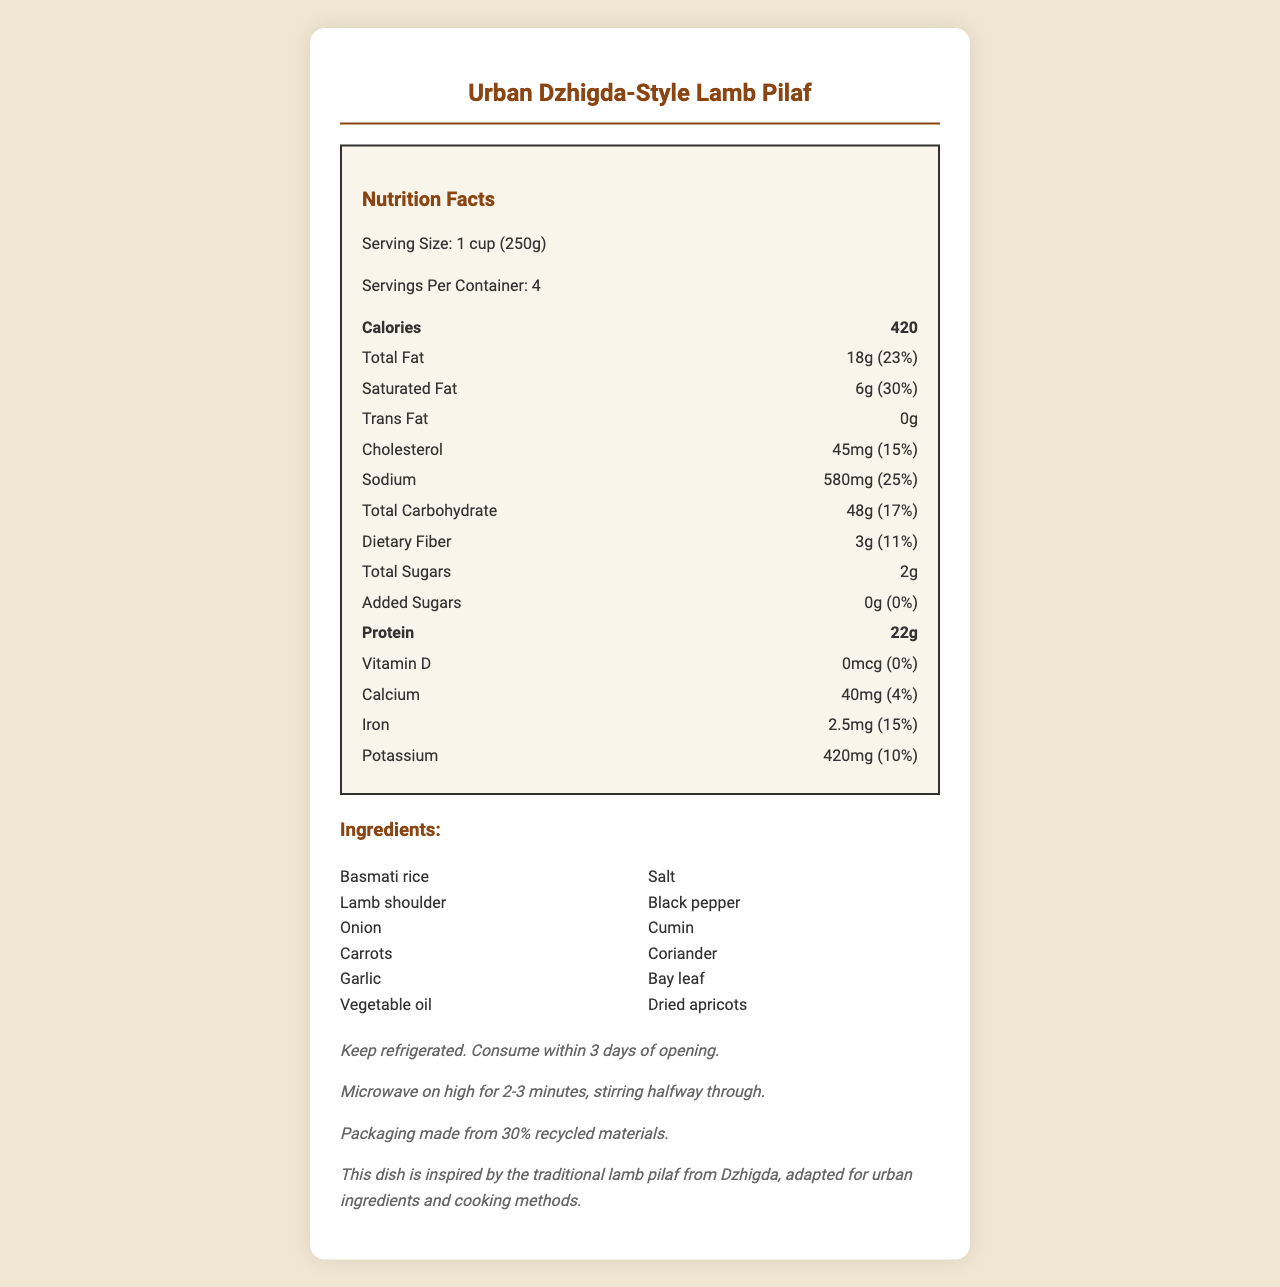what is the serving size for the Urban Dzhigda-Style Lamb Pilaf? The serving size is displayed at the top of the nutrition facts section.
Answer: 1 cup (250g) how many servings are there per container? The servings per container are listed just below the serving size in the nutritional facts section.
Answer: 4 how many grams of protein are in one serving? The amount of protein per serving is specified in the bold nutrition item label for protein.
Answer: 22g what is the sustainability note mentioned in the document? This information is provided at the bottom of the document under the additional information section.
Answer: Packaging made from 30% recycled materials. what are the main ingredients used in the Urban Dzhigda-Style Lamb Pilaf? The ingredients are listed in a section with a heading labeled "Ingredients".
Answer: Basmati rice, Lamb shoulder, Onion, Carrots, Garlic, Vegetable oil, Salt, Black pepper, Cumin, Coriander, Bay leaf, Dried apricots how many calories are in one serving of the Urban Dzhigda-Style Lamb Pilaf? A. 350 B. 420 C. 500 D. 270 The calories per serving are clearly indicated as 420 in the bold nutrition item label for calories.
Answer: B how much sodium does one serving contain? A. 230mg B. 450mg C. 580mg D. 680mg The sodium content per serving is listed as 580mg in the nutrition facts section.
Answer: C is there any added sugar in the Urban Dzhigda-Style Lamb Pilaf? The document shows that added sugars are 0g, and their daily value is also 0%.
Answer: No does the Urban Dzhigda-Style Lamb Pilaf contain any allergens? The document explicitly states in the allergens section that there are no allergens.
Answer: None describe the main idea of the document The document aims to provide comprehensive nutritional information along with storage, reheating instructions, and the cultural inspiration behind the dish.
Answer: The document provides nutritional information for a dish called "Urban Dzhigda-Style Lamb Pilaf," inspired by a traditional Dzhigda recipe but adapted with urban ingredients. It lists serving size, servings per container, calories, various nutritional values, ingredients, allergens, and additional information about storage, reheating, and sustainability. how much vitamin D is in one serving of the Urban Dzhigda-Style Lamb Pilaf? The document indicates that the vitamin D content per serving is 0mcg and has a 0% daily value.
Answer: 0mcg can the sodium content in the dish cause any health issues if consumed excessively? While the document provides the sodium content (580mg), it does not provide context or recommendations regarding health impacts of consuming this amount.
Answer: Cannot be determined 